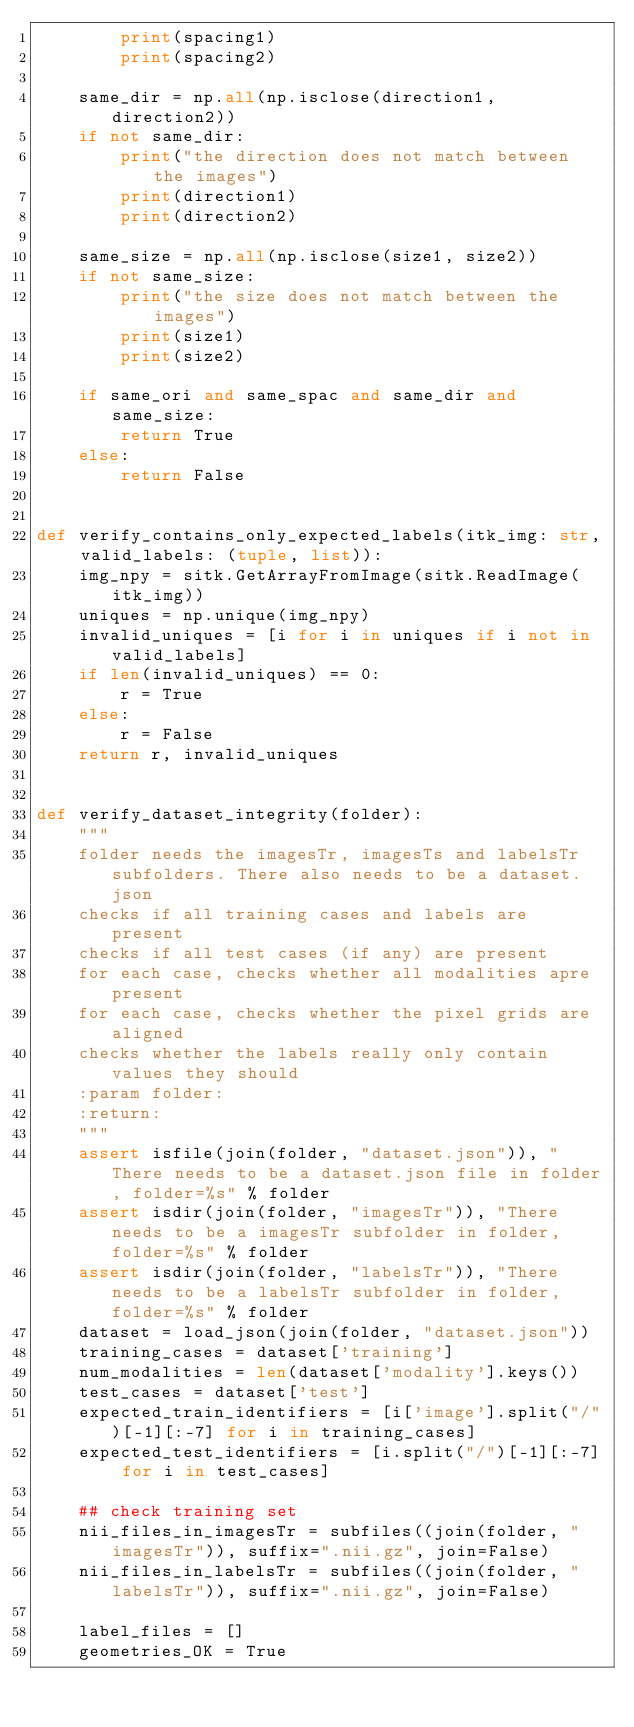Convert code to text. <code><loc_0><loc_0><loc_500><loc_500><_Python_>        print(spacing1)
        print(spacing2)

    same_dir = np.all(np.isclose(direction1, direction2))
    if not same_dir:
        print("the direction does not match between the images")
        print(direction1)
        print(direction2)

    same_size = np.all(np.isclose(size1, size2))
    if not same_size:
        print("the size does not match between the images")
        print(size1)
        print(size2)

    if same_ori and same_spac and same_dir and same_size:
        return True
    else:
        return False


def verify_contains_only_expected_labels(itk_img: str, valid_labels: (tuple, list)):
    img_npy = sitk.GetArrayFromImage(sitk.ReadImage(itk_img))
    uniques = np.unique(img_npy)
    invalid_uniques = [i for i in uniques if i not in valid_labels]
    if len(invalid_uniques) == 0:
        r = True
    else:
        r = False
    return r, invalid_uniques


def verify_dataset_integrity(folder):
    """
    folder needs the imagesTr, imagesTs and labelsTr subfolders. There also needs to be a dataset.json
    checks if all training cases and labels are present
    checks if all test cases (if any) are present
    for each case, checks whether all modalities apre present
    for each case, checks whether the pixel grids are aligned
    checks whether the labels really only contain values they should
    :param folder:
    :return:
    """
    assert isfile(join(folder, "dataset.json")), "There needs to be a dataset.json file in folder, folder=%s" % folder
    assert isdir(join(folder, "imagesTr")), "There needs to be a imagesTr subfolder in folder, folder=%s" % folder
    assert isdir(join(folder, "labelsTr")), "There needs to be a labelsTr subfolder in folder, folder=%s" % folder
    dataset = load_json(join(folder, "dataset.json"))
    training_cases = dataset['training']
    num_modalities = len(dataset['modality'].keys())
    test_cases = dataset['test']
    expected_train_identifiers = [i['image'].split("/")[-1][:-7] for i in training_cases]
    expected_test_identifiers = [i.split("/")[-1][:-7] for i in test_cases]

    ## check training set
    nii_files_in_imagesTr = subfiles((join(folder, "imagesTr")), suffix=".nii.gz", join=False)
    nii_files_in_labelsTr = subfiles((join(folder, "labelsTr")), suffix=".nii.gz", join=False)

    label_files = []
    geometries_OK = True</code> 